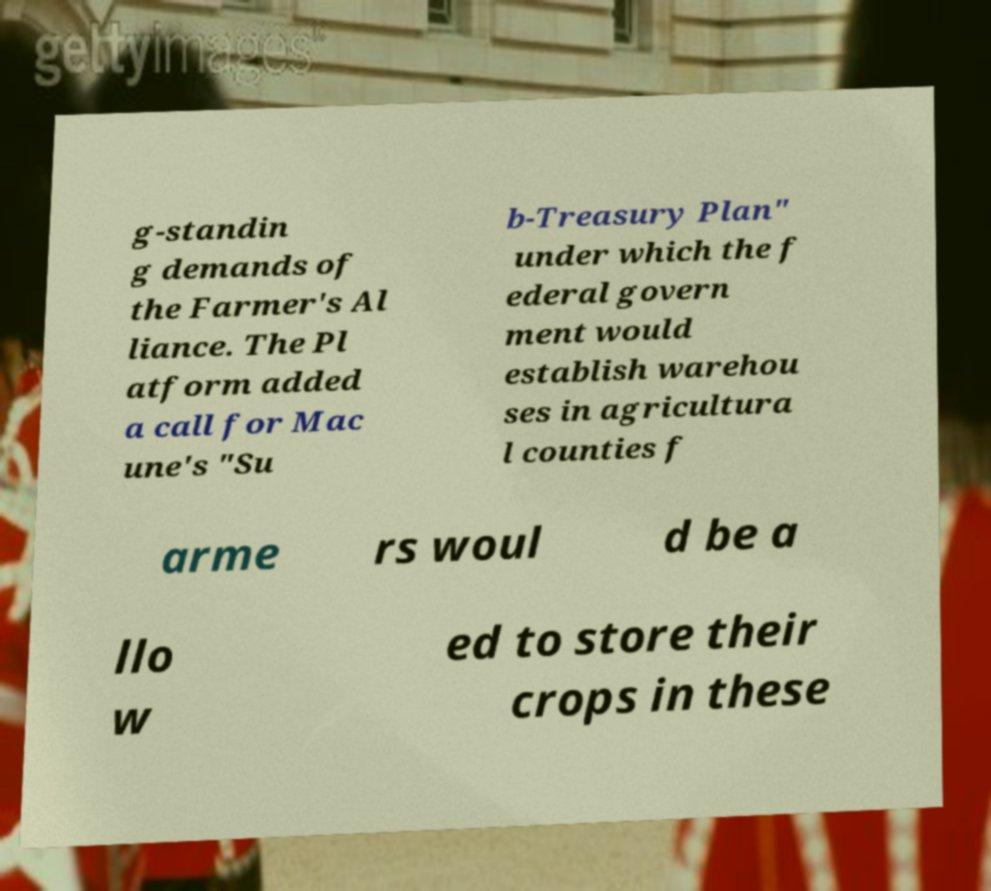Please identify and transcribe the text found in this image. g-standin g demands of the Farmer's Al liance. The Pl atform added a call for Mac une's "Su b-Treasury Plan" under which the f ederal govern ment would establish warehou ses in agricultura l counties f arme rs woul d be a llo w ed to store their crops in these 